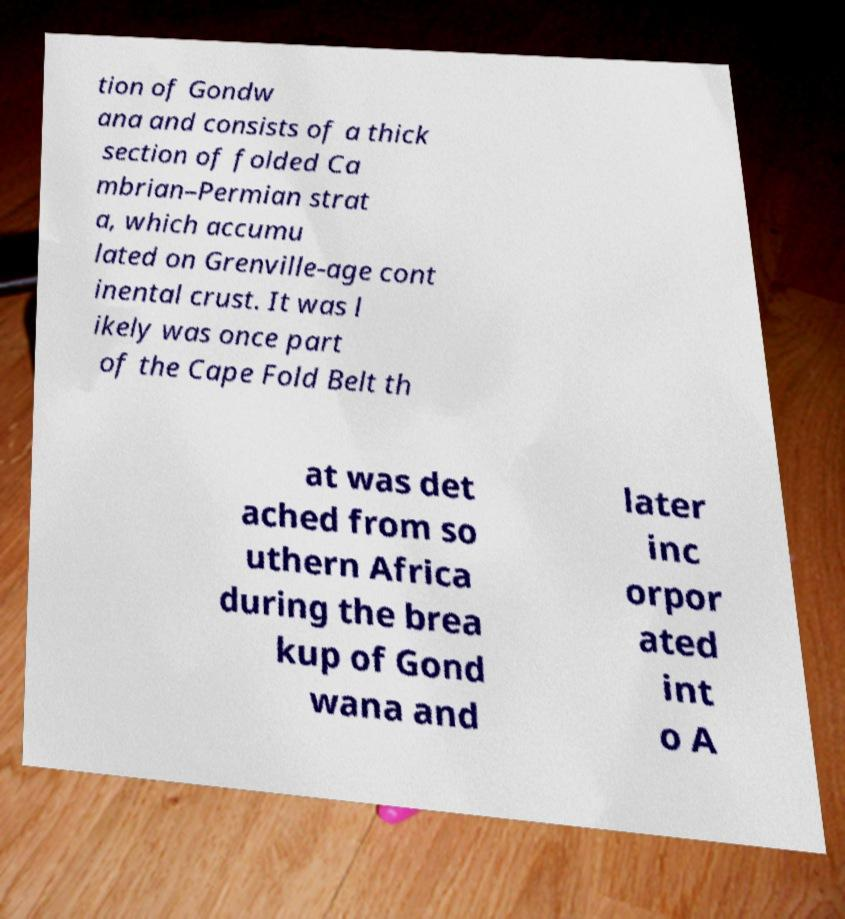Can you read and provide the text displayed in the image?This photo seems to have some interesting text. Can you extract and type it out for me? tion of Gondw ana and consists of a thick section of folded Ca mbrian–Permian strat a, which accumu lated on Grenville-age cont inental crust. It was l ikely was once part of the Cape Fold Belt th at was det ached from so uthern Africa during the brea kup of Gond wana and later inc orpor ated int o A 